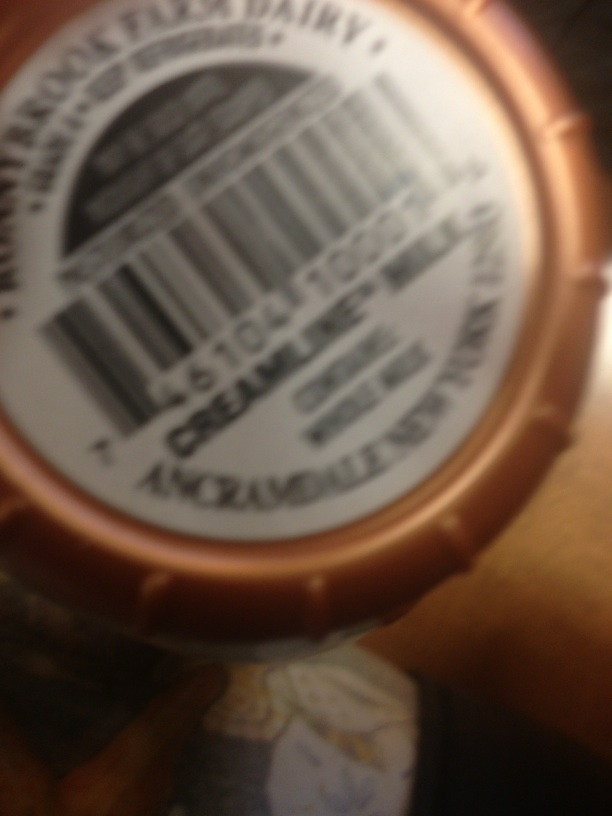What does this say? The image is too blurry to read the text clearly, but it appears to be a label, potentially on a food or beverage item. For a more precise answer, a clearer image or additional context is needed. 